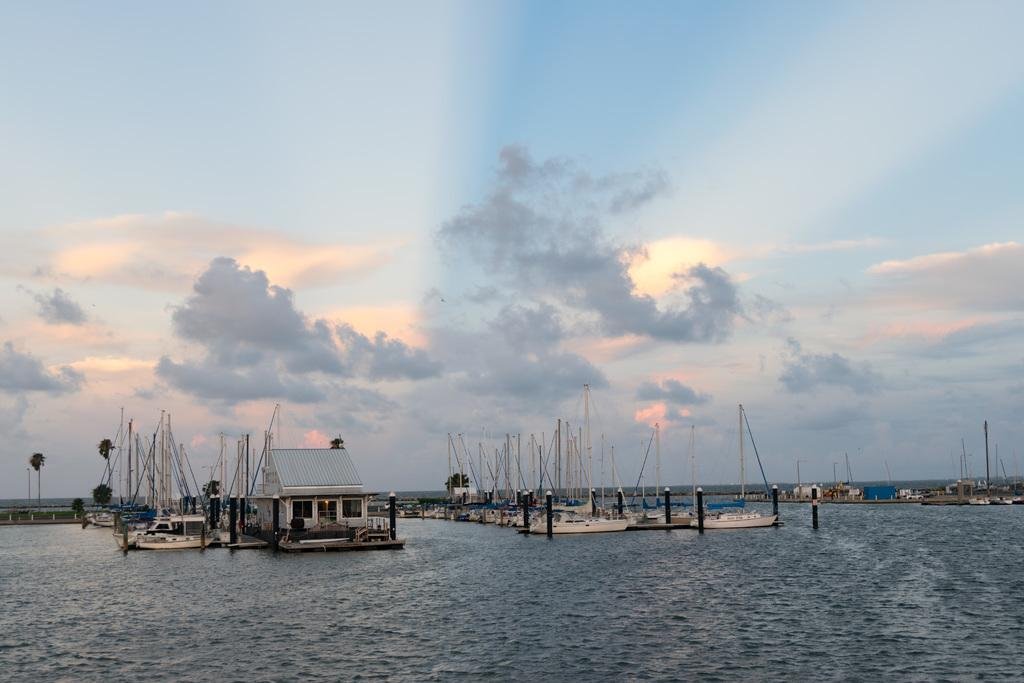What type of vehicles can be seen in the image? There are boats in the image. What structures are present in the image? There are poles and a house in the image. What type of natural elements can be seen in the image? There are trees in the image. What is the foreground of the image composed of? The foreground of the image contains water. What is visible at the top of the image? The sky is visible at the top of the image. What type of fuel is being used by the trees in the image? There is no fuel being used by the trees in the image; trees do not use fuel. How many bottles can be seen lifting the boats in the image? There are no bottles present in the image, and they are not lifting the boats. 